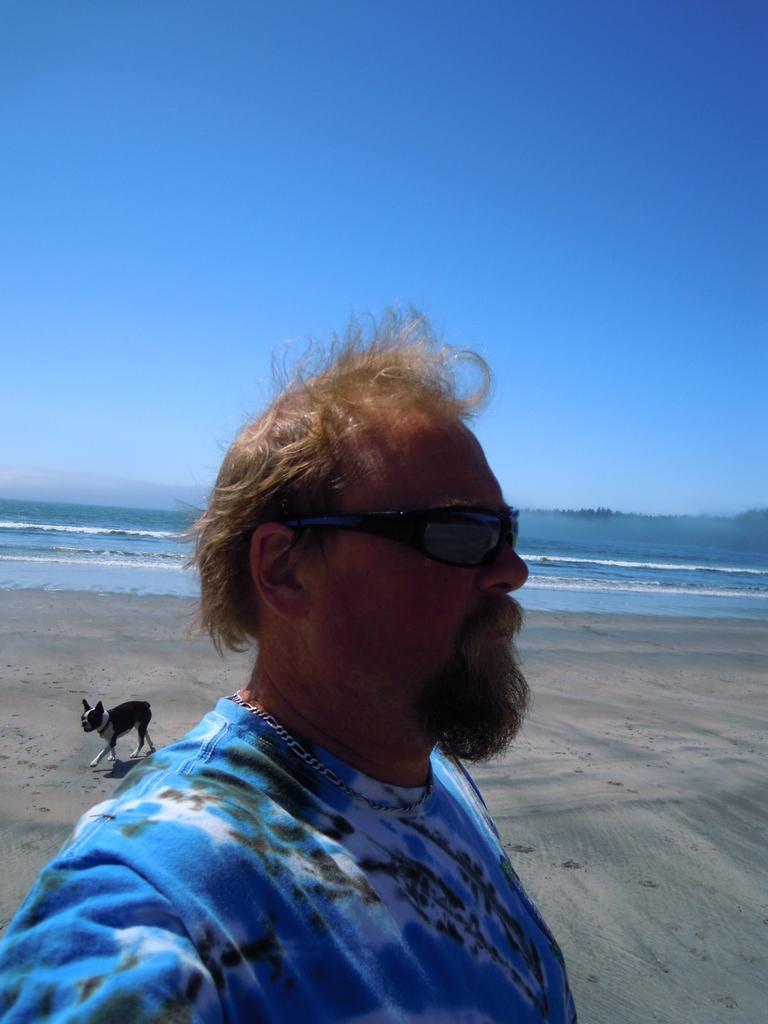How would you summarize this image in a sentence or two? As we can see in the image in the front there is a man standing and wearing goggles. There is a black color dog, water and sky. 